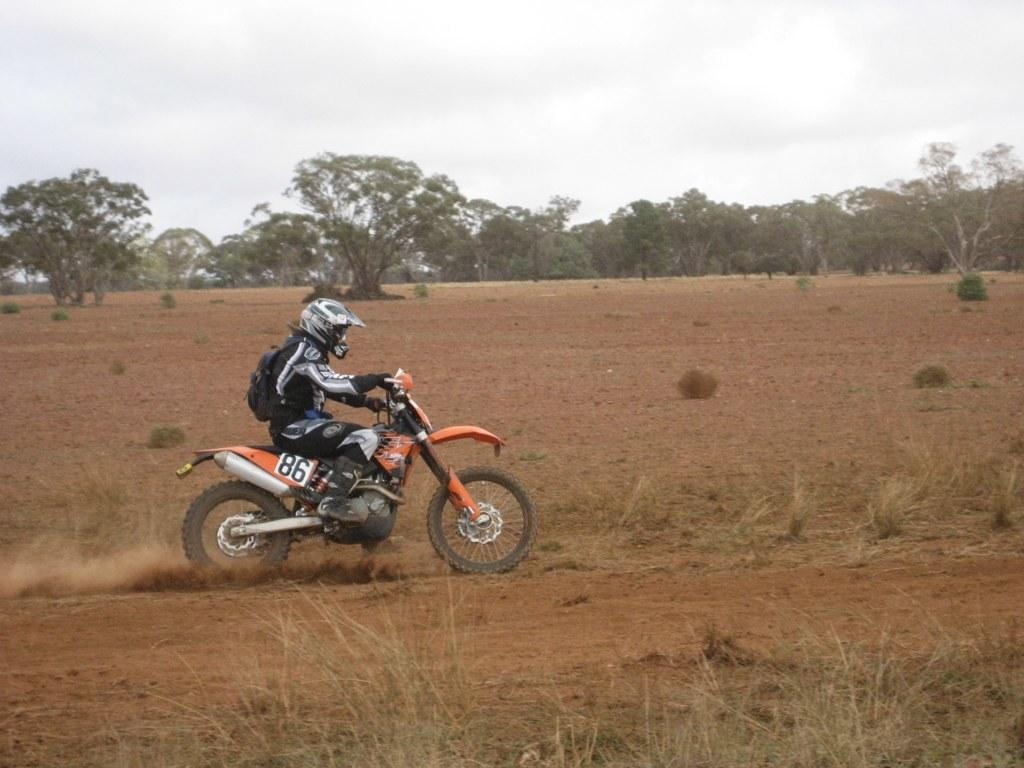What can be seen in the sky in the image? The sky is visible in the image. What type of vegetation is present in the image? There are trees and plants in the image. How are some of the plants depicted in the image? Some plants are truncated towards the bottom of the image. What is the person in the image doing? There is a person riding a motorcycle in the image. How many potatoes can be seen in the image? There are no potatoes present in the image. Are the person's friends riding alongside them on the motorcycle? The image does not show any friends accompanying the person on the motorcycle. 